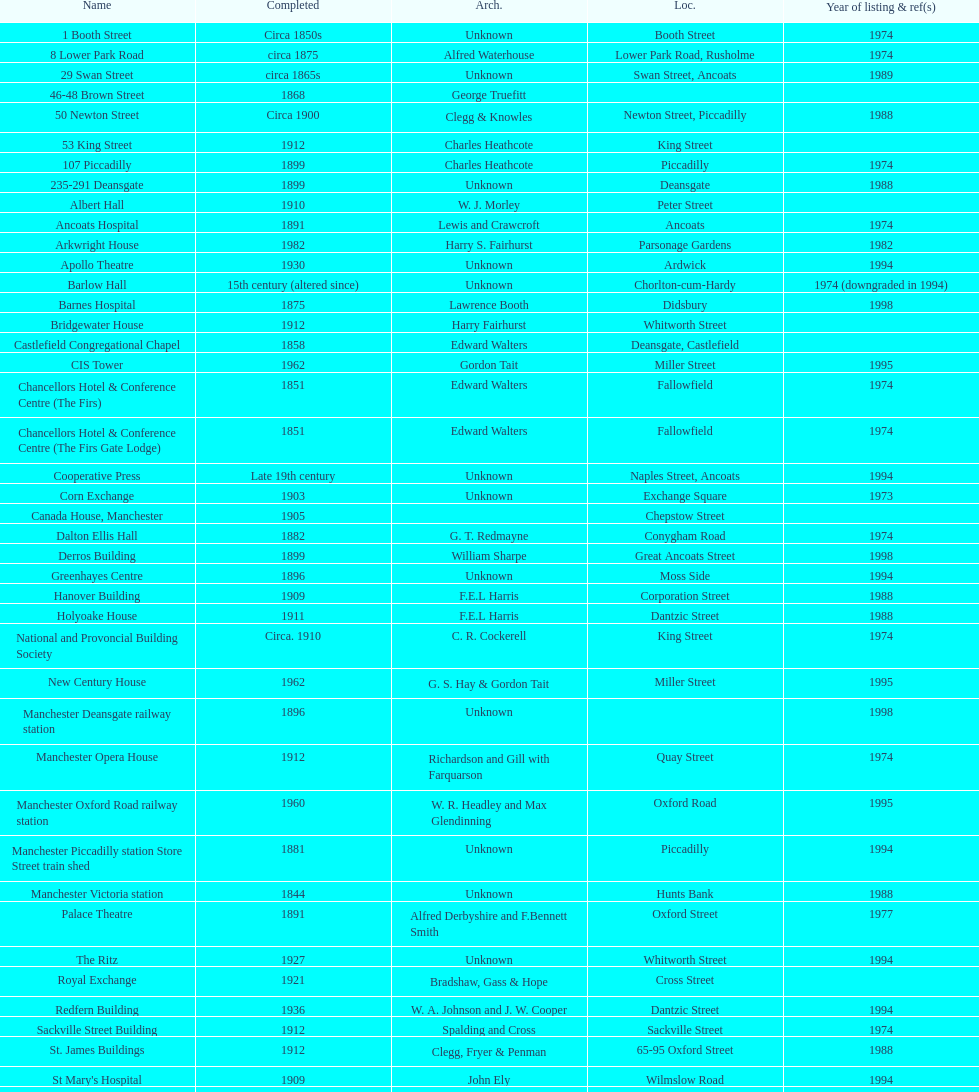Was charles heathcote the architect of ancoats hospital and apollo theatre? No. 